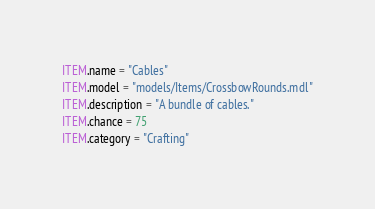<code> <loc_0><loc_0><loc_500><loc_500><_Lua_>ITEM.name = "Cables"
ITEM.model = "models/Items/CrossbowRounds.mdl"
ITEM.description = "A bundle of cables."
ITEM.chance = 75
ITEM.category = "Crafting"</code> 